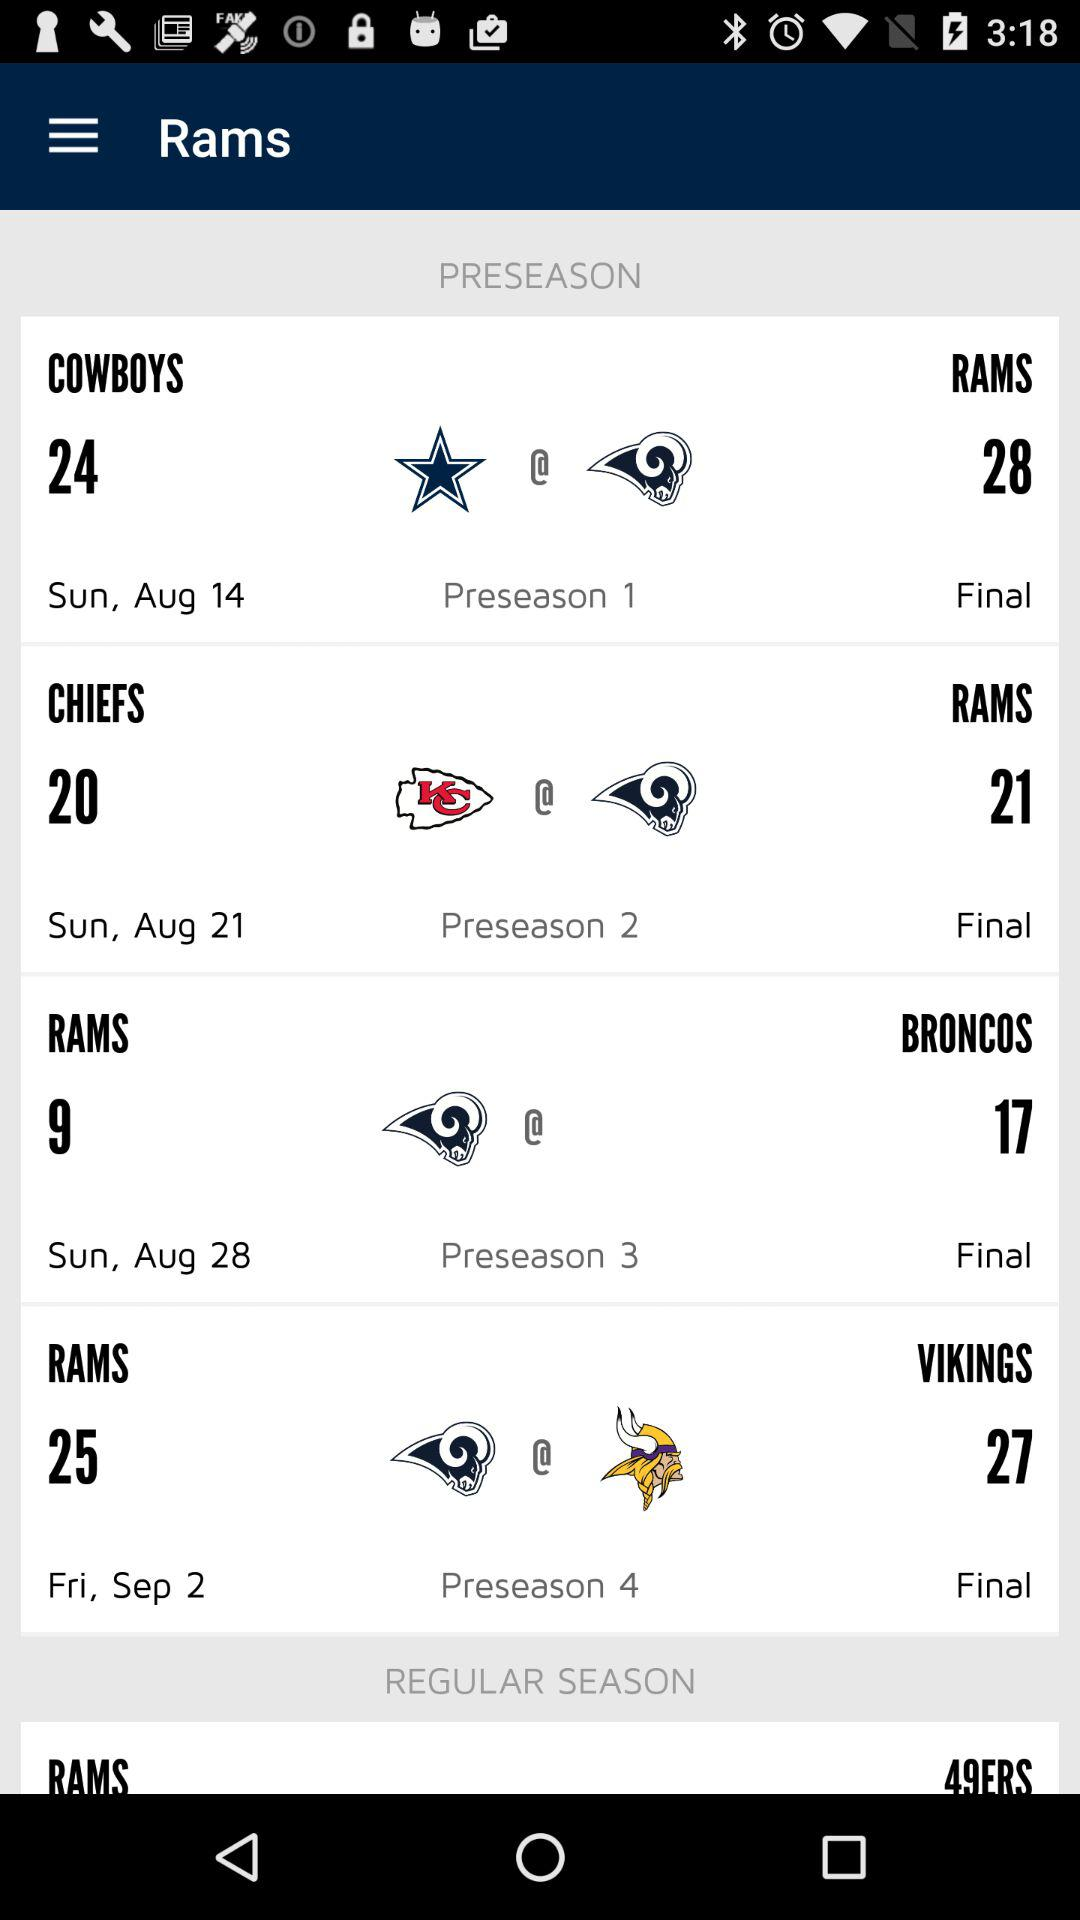How many preseason games are there?
Answer the question using a single word or phrase. 4 